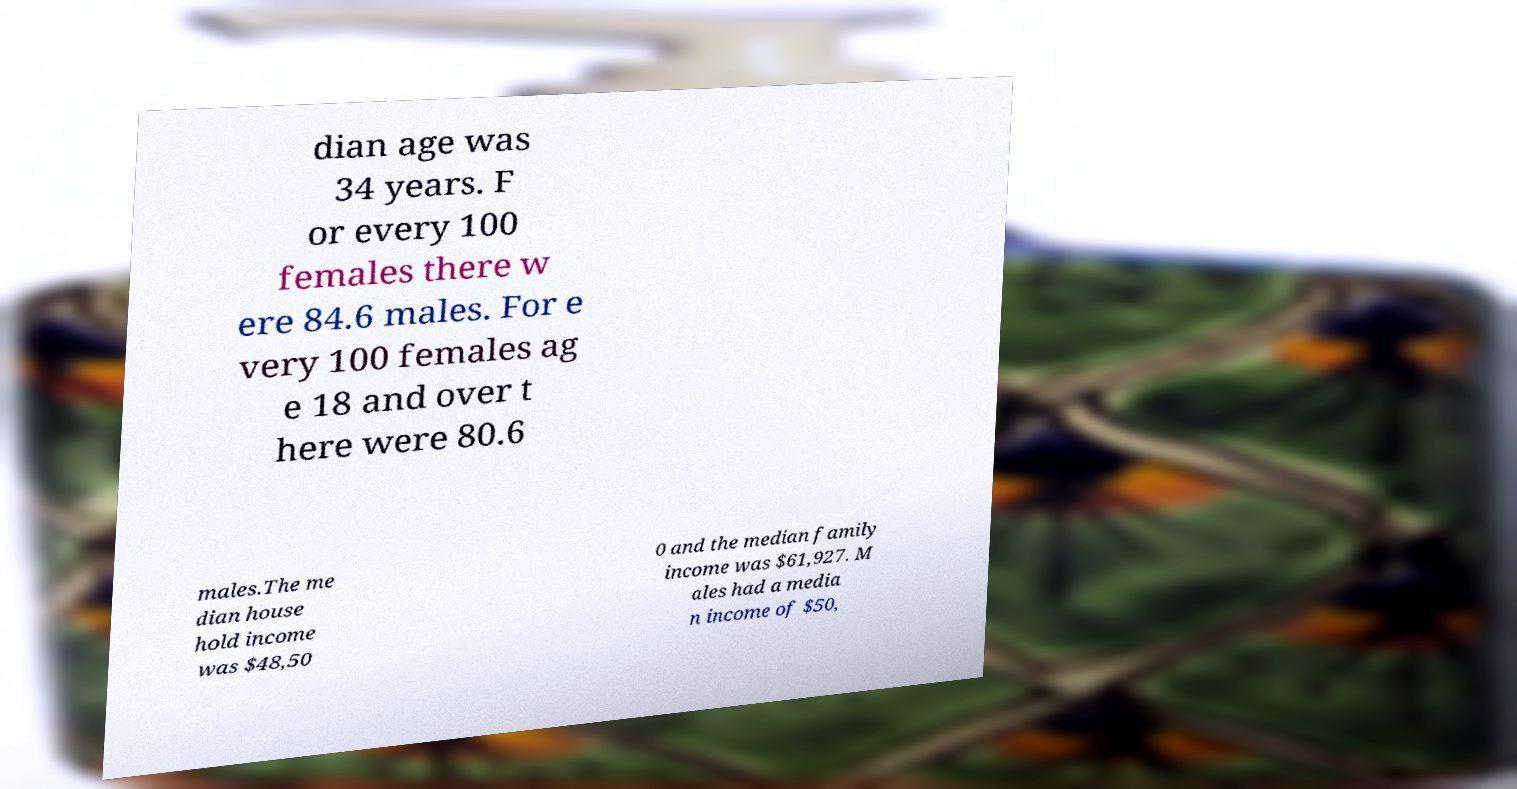Could you extract and type out the text from this image? dian age was 34 years. F or every 100 females there w ere 84.6 males. For e very 100 females ag e 18 and over t here were 80.6 males.The me dian house hold income was $48,50 0 and the median family income was $61,927. M ales had a media n income of $50, 